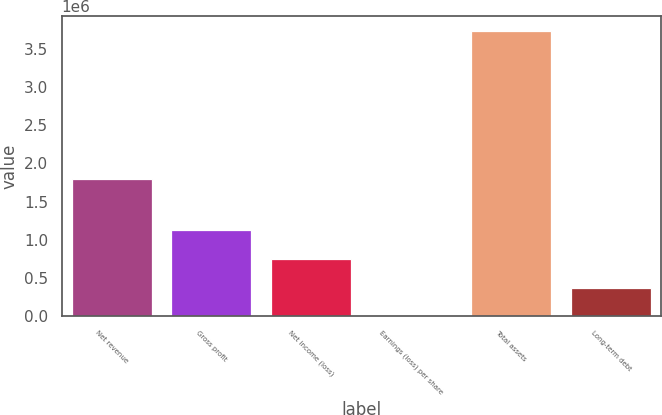Convert chart to OTSL. <chart><loc_0><loc_0><loc_500><loc_500><bar_chart><fcel>Net revenue<fcel>Gross profit<fcel>Net income (loss)<fcel>Earnings (loss) per share<fcel>Total assets<fcel>Long-term debt<nl><fcel>1.79289e+06<fcel>1.12135e+06<fcel>747569<fcel>1.57<fcel>3.73784e+06<fcel>373786<nl></chart> 